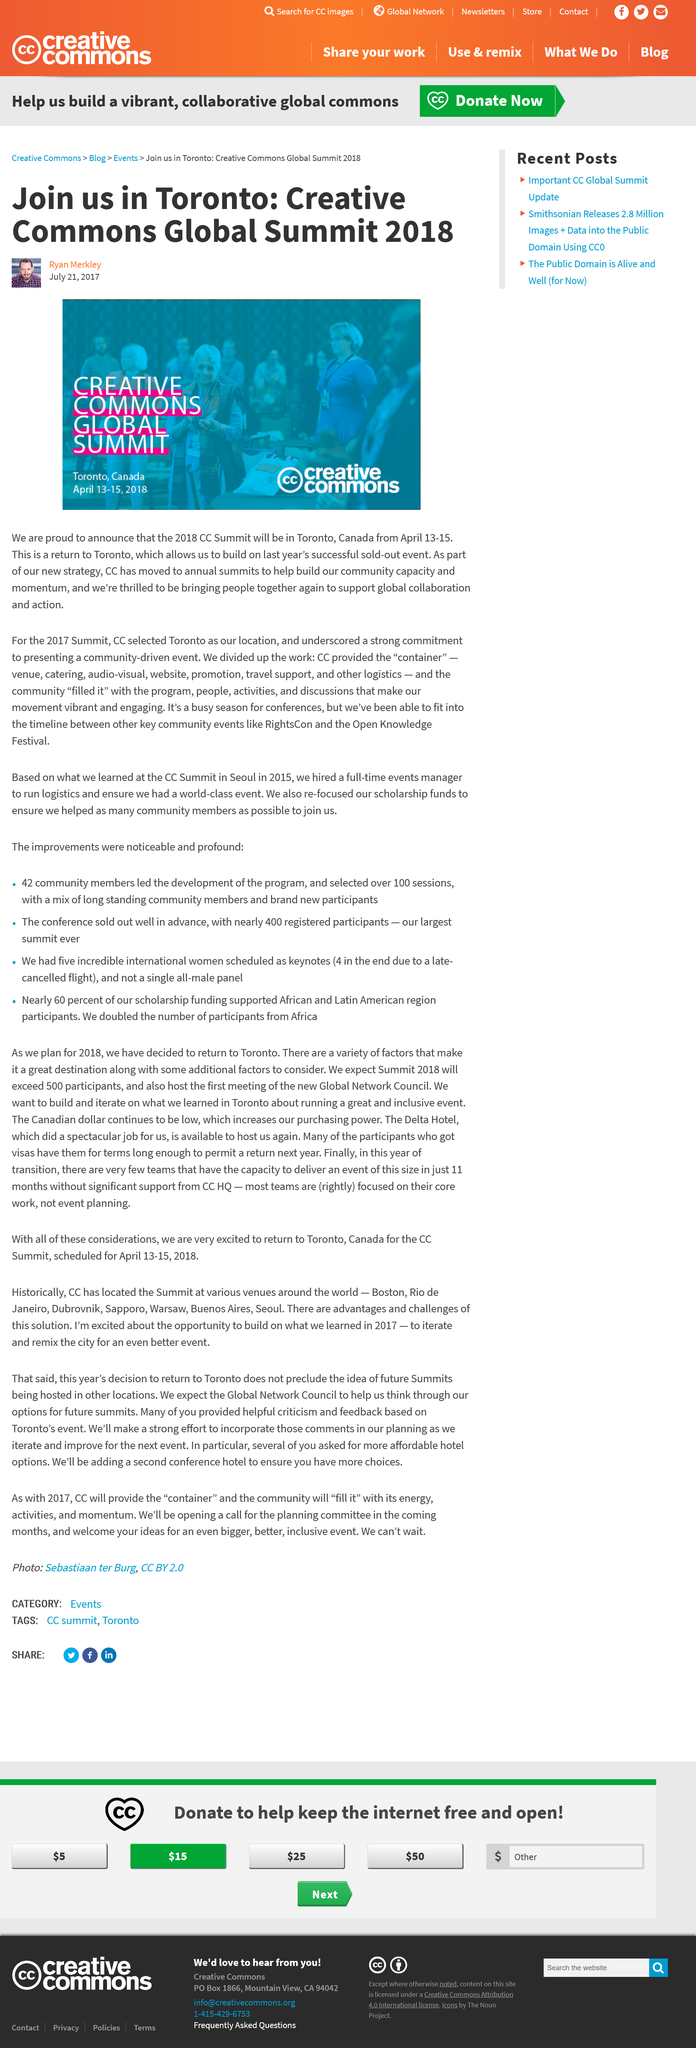Point out several critical features in this image. The CC Summit was held in Toronto, Canada in 2017. Ryan Merkley's headshot is depicted in the image. The 2018 CC Summit took place in Toronto, Canada. 